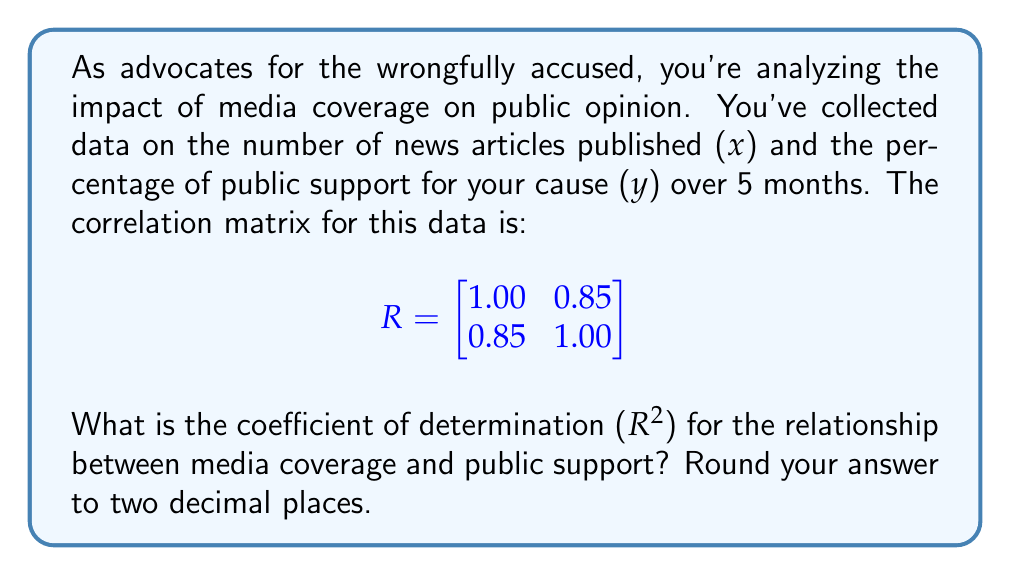Teach me how to tackle this problem. To solve this problem, we'll follow these steps:

1) The correlation matrix R provides the correlation coefficient (r) between the two variables.

2) In a 2x2 correlation matrix, the off-diagonal elements represent the correlation coefficient. Here, r = 0.85.

3) The coefficient of determination (R²) is the square of the correlation coefficient (r).

4) Calculate R² = r² = (0.85)²

5) R² = 0.7225

6) Rounding to two decimal places: R² ≈ 0.72

This means that approximately 72% of the variation in public support can be explained by the variation in media coverage, indicating a strong relationship between these variables.
Answer: 0.72 